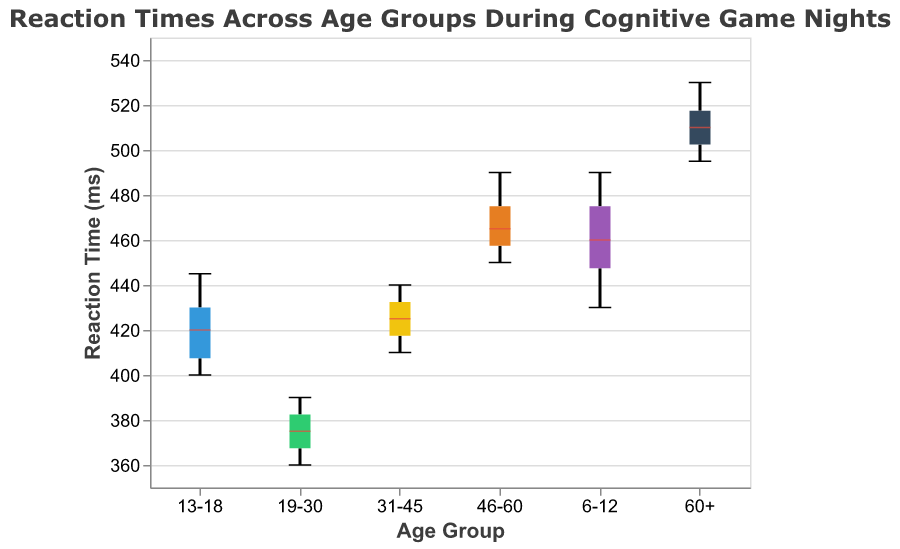What is the title of the figure? The title is located at the top of the figure and states the main subject being analyzed. It provides context for the viewer.
Answer: Reaction Times Across Age Groups During Cognitive Game Nights What is the median reaction time for the 19-30 age group? To find the median reaction time for the 19-30 age group, look at the middle line inside the box for this age group in the figure. This line represents the median value.
Answer: 375 ms Which age group has the highest median reaction time? By comparing the middle lines (medians) inside the boxes of each age group, the 60+ age group has the highest median reaction time.
Answer: 510 ms What is the range of reaction times for the 6-12 age group? The range is determined by the minimum and maximum reaction times, which are represented by the lower and upper whiskers of the box plot.
Answer: 430 - 490 ms What is the interquartile range (IQR) for the 13-18 age group? The IQR is the difference between the upper quartile (Q3) and lower quartile (Q1). This can be visualized by the distance between the top and bottom edges of the box for this age group.
Answer: 15 ms Which age group has the most consistent reaction times? Consistency can be assessed by the size of the box (IQR) – the smaller the box, the more consistent the reaction times. The 19-30 age group has the smallest IQR, indicating the most consistent reaction times.
Answer: 19-30 Between the 31-45 and 46-60 age groups, which has a larger spread in reaction times? The spread is indicated by the distance between the minimum and maximum whiskers. The 46-60 age group has a larger spread compared to the 31-45 age group.
Answer: 46-60 What is the difference between the median reaction times of the 6-12 and 60+ age groups? First, find the median reaction times for each group from the middle lines inside the boxes. Then, subtract the median of the 6-12 group from the median of the 60+ group.
Answer: 55 ms How does the median reaction time for the 46-60 age group compare to the 19-30 age group? Look at the middle lines in the boxes for both age groups; the 46-60 age group has a higher median reaction time compared to the 19-30 age group.
Answer: Higher What is the trend in median reaction times across age groups? Observing the medians from left to right across the plot, the trend generally shows increasing median reaction times as age increases.
Answer: Increasing 